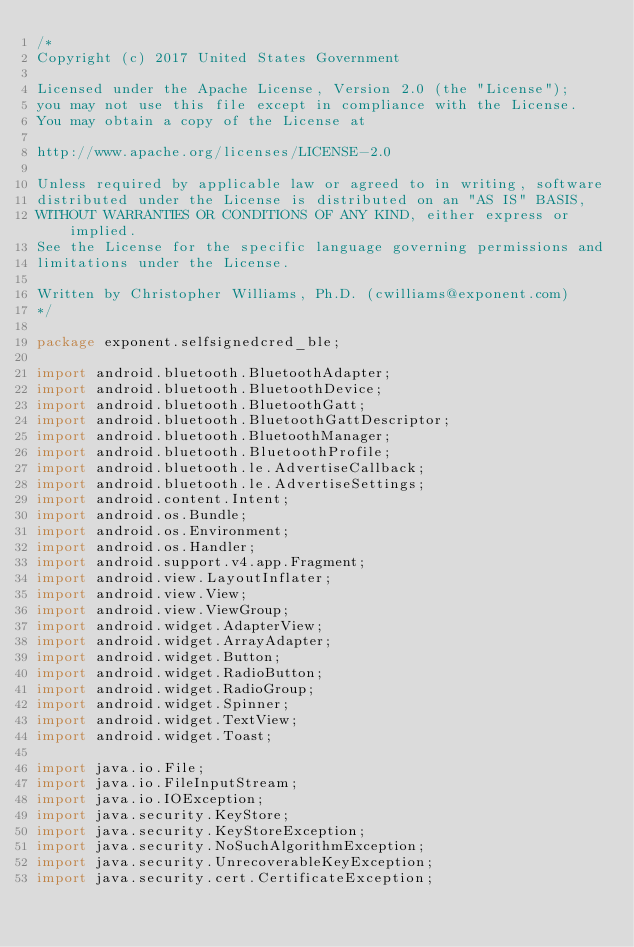<code> <loc_0><loc_0><loc_500><loc_500><_Java_>/*
Copyright (c) 2017 United States Government

Licensed under the Apache License, Version 2.0 (the "License");
you may not use this file except in compliance with the License.
You may obtain a copy of the License at

http://www.apache.org/licenses/LICENSE-2.0

Unless required by applicable law or agreed to in writing, software
distributed under the License is distributed on an "AS IS" BASIS,
WITHOUT WARRANTIES OR CONDITIONS OF ANY KIND, either express or implied.
See the License for the specific language governing permissions and
limitations under the License.

Written by Christopher Williams, Ph.D. (cwilliams@exponent.com)
*/

package exponent.selfsignedcred_ble;

import android.bluetooth.BluetoothAdapter;
import android.bluetooth.BluetoothDevice;
import android.bluetooth.BluetoothGatt;
import android.bluetooth.BluetoothGattDescriptor;
import android.bluetooth.BluetoothManager;
import android.bluetooth.BluetoothProfile;
import android.bluetooth.le.AdvertiseCallback;
import android.bluetooth.le.AdvertiseSettings;
import android.content.Intent;
import android.os.Bundle;
import android.os.Environment;
import android.os.Handler;
import android.support.v4.app.Fragment;
import android.view.LayoutInflater;
import android.view.View;
import android.view.ViewGroup;
import android.widget.AdapterView;
import android.widget.ArrayAdapter;
import android.widget.Button;
import android.widget.RadioButton;
import android.widget.RadioGroup;
import android.widget.Spinner;
import android.widget.TextView;
import android.widget.Toast;

import java.io.File;
import java.io.FileInputStream;
import java.io.IOException;
import java.security.KeyStore;
import java.security.KeyStoreException;
import java.security.NoSuchAlgorithmException;
import java.security.UnrecoverableKeyException;
import java.security.cert.CertificateException;</code> 